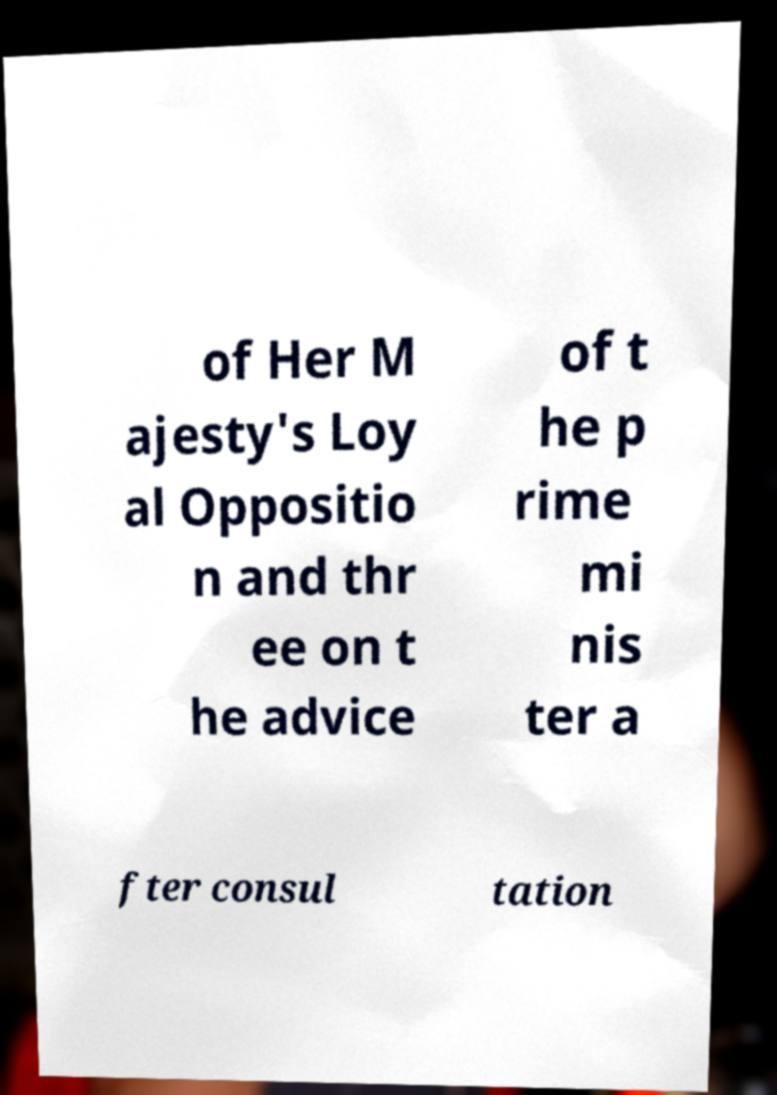Can you read and provide the text displayed in the image?This photo seems to have some interesting text. Can you extract and type it out for me? of Her M ajesty's Loy al Oppositio n and thr ee on t he advice of t he p rime mi nis ter a fter consul tation 